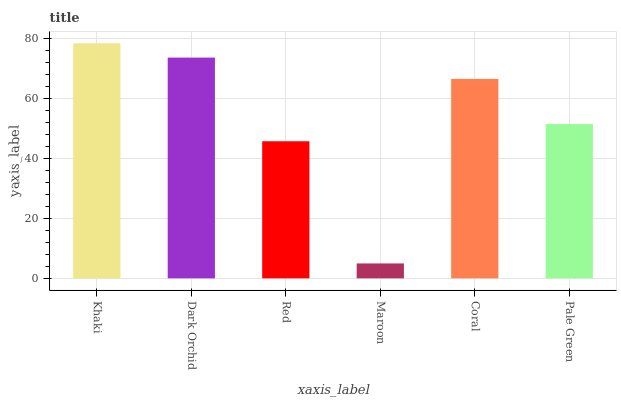Is Maroon the minimum?
Answer yes or no. Yes. Is Khaki the maximum?
Answer yes or no. Yes. Is Dark Orchid the minimum?
Answer yes or no. No. Is Dark Orchid the maximum?
Answer yes or no. No. Is Khaki greater than Dark Orchid?
Answer yes or no. Yes. Is Dark Orchid less than Khaki?
Answer yes or no. Yes. Is Dark Orchid greater than Khaki?
Answer yes or no. No. Is Khaki less than Dark Orchid?
Answer yes or no. No. Is Coral the high median?
Answer yes or no. Yes. Is Pale Green the low median?
Answer yes or no. Yes. Is Pale Green the high median?
Answer yes or no. No. Is Dark Orchid the low median?
Answer yes or no. No. 